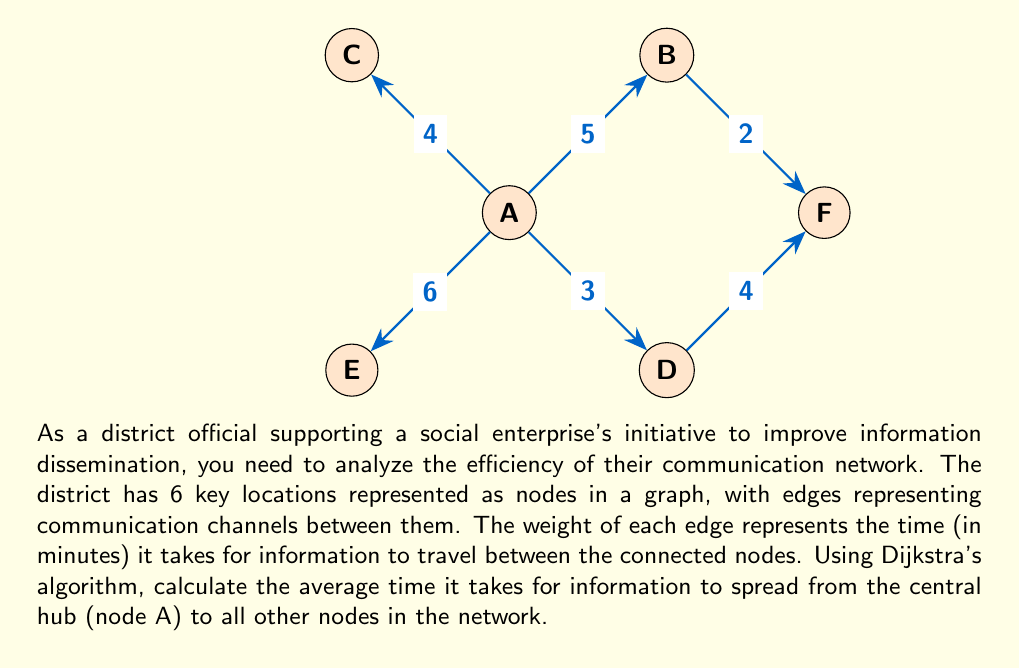Provide a solution to this math problem. To solve this problem, we'll use Dijkstra's algorithm to find the shortest path from node A to all other nodes. Then, we'll calculate the average time.

Step 1: Apply Dijkstra's algorithm
Starting from node A:
- A to B: 5 minutes
- A to C: 4 minutes
- A to D: 3 minutes
- A to E: 6 minutes
- A to F: min(A to B + B to F, A to D + D to F) = min(5 + 2, 3 + 4) = 7 minutes

Step 2: Sum up all the shortest path times
Total time = 5 + 4 + 3 + 6 + 7 = 25 minutes

Step 3: Calculate the average time
Average time = Total time / Number of destination nodes
$$ \text{Average time} = \frac{25}{5} = 5 \text{ minutes} $$

Therefore, on average, it takes 5 minutes for information to spread from the central hub (node A) to all other nodes in the network.
Answer: 5 minutes 